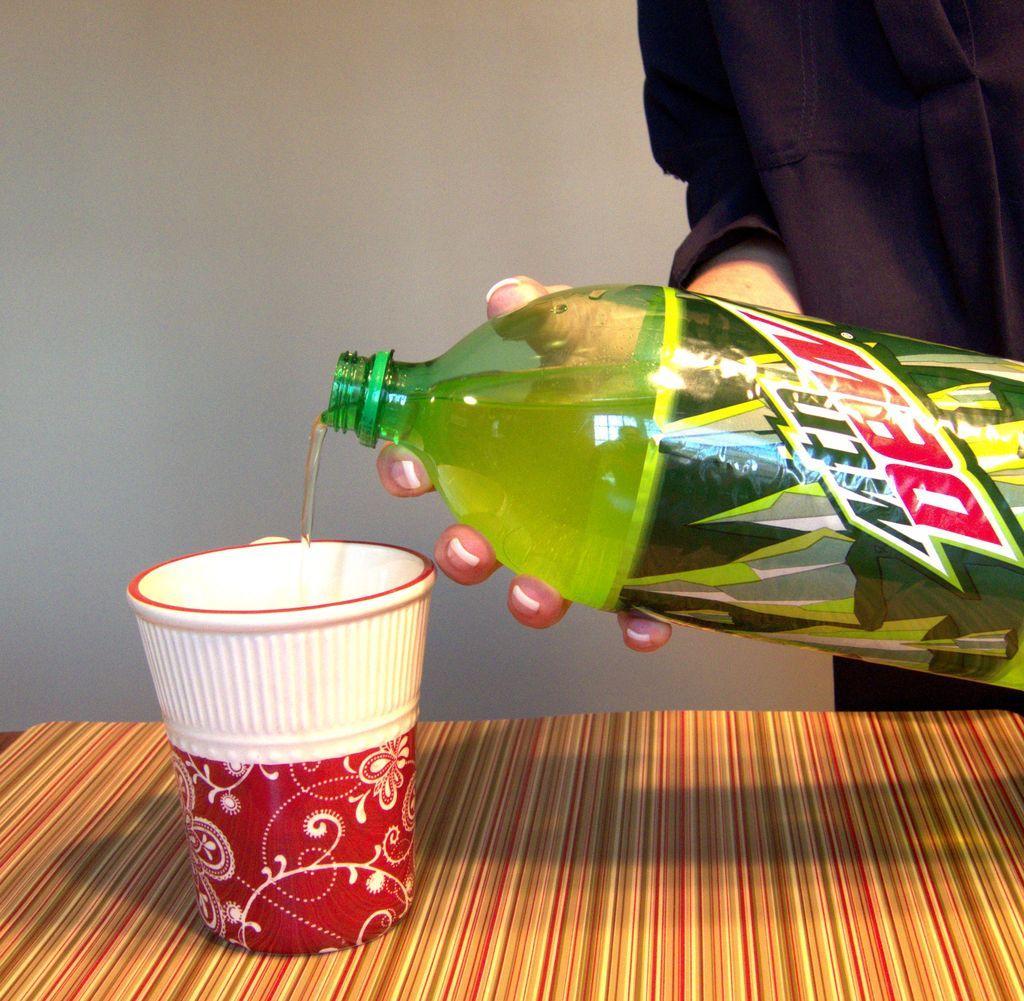Can you describe this image briefly? The image has a glass on a table and a person is pouring drink into the glass in the background there is a white color wall. 